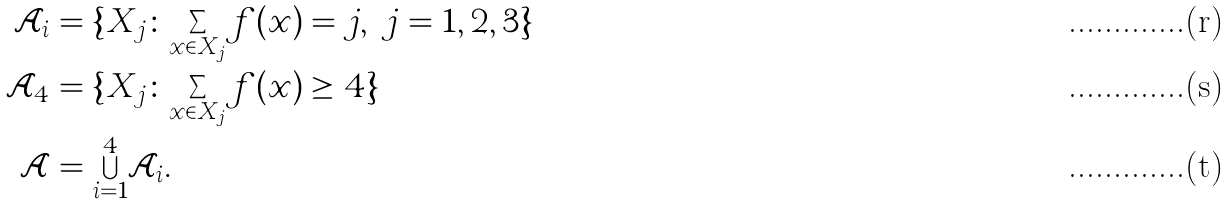Convert formula to latex. <formula><loc_0><loc_0><loc_500><loc_500>\mathcal { A } _ { i } & = \{ X _ { j } \colon { \sum _ { x \in X _ { j } } } f ( x ) = j , \ j = 1 , 2 , 3 \} \\ \mathcal { A } _ { 4 } & = \{ X _ { j } \colon { \sum _ { x \in X _ { j } } } f ( x ) \geq 4 \} \\ \mathcal { A } & = { \bigcup _ { i = 1 } ^ { 4 } } \mathcal { A } _ { i } .</formula> 